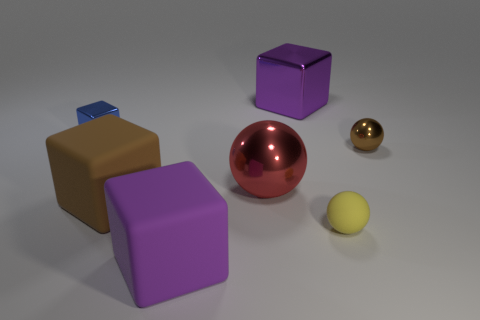Are there any tiny spheres made of the same material as the big red thing?
Provide a succinct answer. Yes. How many things are spheres or large purple metal spheres?
Make the answer very short. 3. Are the yellow thing and the thing right of the small yellow rubber sphere made of the same material?
Make the answer very short. No. There is a purple block that is in front of the large purple shiny cube; how big is it?
Provide a succinct answer. Large. Are there fewer small brown metal things than big blue matte cubes?
Ensure brevity in your answer.  No. Are there any big things of the same color as the big shiny cube?
Keep it short and to the point. Yes. What shape is the tiny thing that is on the left side of the brown metallic ball and behind the large brown block?
Provide a succinct answer. Cube. There is a big metal thing that is behind the small thing to the left of the big purple matte object; what shape is it?
Provide a short and direct response. Cube. Is the tiny brown thing the same shape as the blue object?
Offer a very short reply. No. There is a purple block that is on the right side of the cube in front of the small rubber sphere; how many large cubes are left of it?
Provide a short and direct response. 2. 